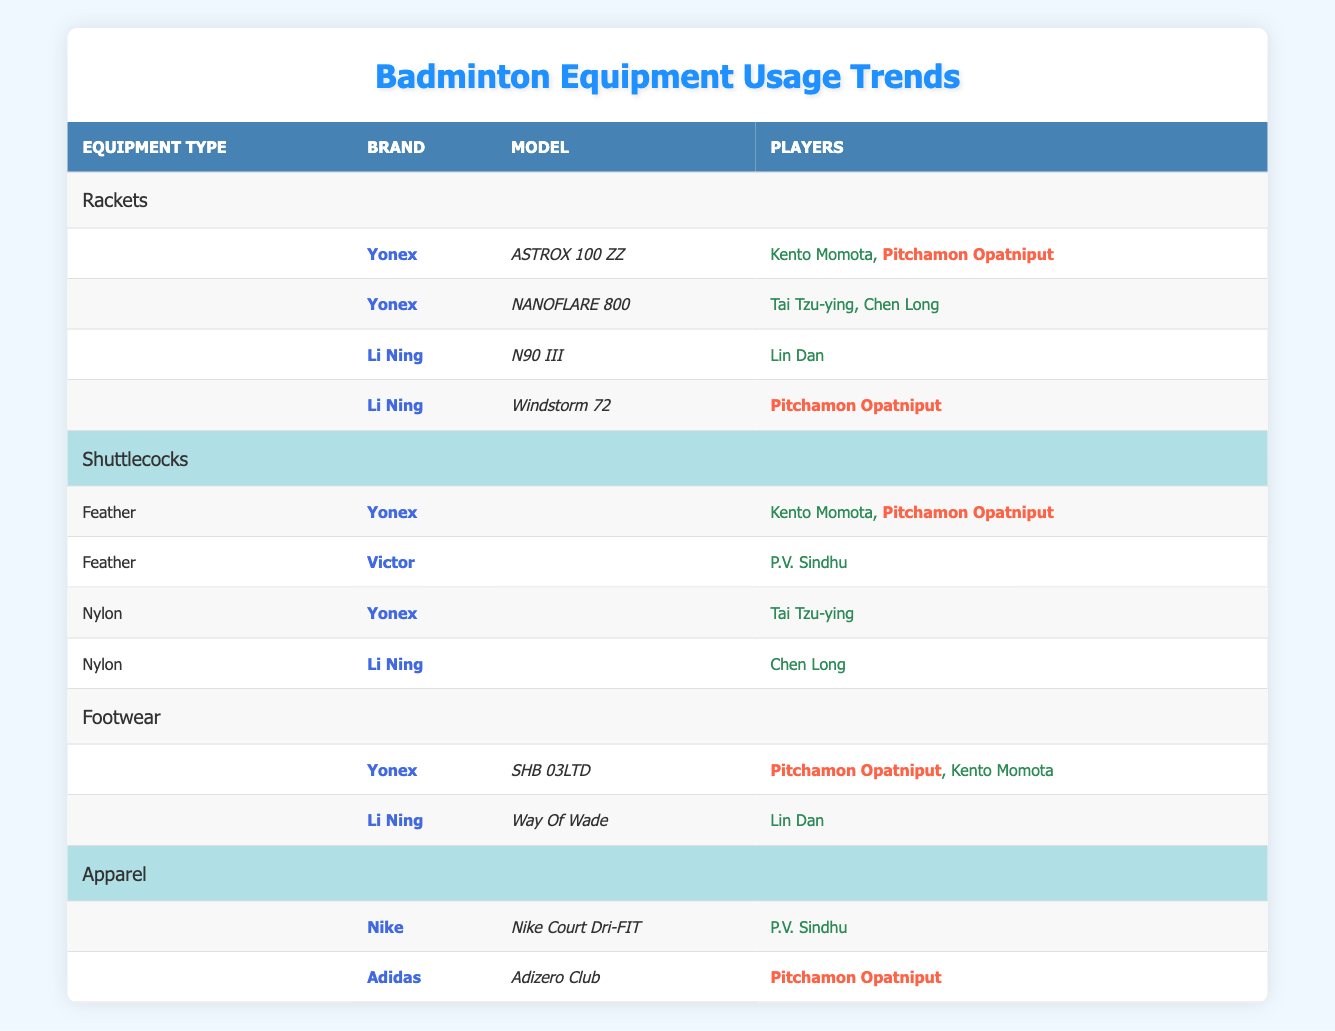What types of rackets does Pitchamon Opatniput use? From the rackets section of the table, I can see that Pitchamon Opatniput uses two models: "ASTROX 100 ZZ" by Yonex and "Windstorm 72" by Li Ning.
Answer: "ASTROX 100 ZZ" and "Windstorm 72" Which brands of footwear are used by Kento Momota? Looking under the footwear section, Kento Momota uses footwear from the brand Yonex, specifically the model "SHB 03LTD." There are no other brands listed for him in the table.
Answer: Yonex True or False: Pitchamon Opatniput uses shuttlecocks from both Yonex and Victor. The table indicates that Pitchamon Opatniput is associated with shuttlecocks from Yonex, but there is no mention of using Victor. Therefore, this statement is false.
Answer: False How many different types of apparel does Pitchamon Opatniput wear according to the table? The table shows that Pitchamon Opatniput uses apparel from Adidas with the model "Adizero Club." There are no other apparel brands listed for her. Thus, there is just one type of apparel.
Answer: 1 If you sum the total number of different racket models used by all players mentioned, what is the total? Upon examining the rackets section, there are four unique racket models: "ASTROX 100 ZZ," "NANOFLARE 800," "N90 III," and "Windstorm 72." Therefore, the total number of different racket models used by all players is 4.
Answer: 4 Which brands of shuttlecocks does Tai Tzu-ying use? In the nylon shuttlecock section, Tai Tzu-ying is listed as using Yonex. There are no other shuttlecock brands associated with Tai Tzu-ying in the table.
Answer: Yonex What is the brand and model of the footwear that Pitchamon Opatniput uses? The footwear section reveals that Pitchamon Opatniput uses the "SHB 03LTD" model from the brand Yonex, along with another brand mentioned. Hence, the brand and model are Yonex and "SHB 03LTD," respectively.
Answer: Yonex, SHB 03LTD How many players use the "Adizero Club" apparel model? The apparel section shows that only P.V. Sindhu uses "Nike Court Dri-FIT," while Pitchamon Opatniput is the only one listed for the "Adizero Club" model from Adidas. Hence, only one player uses this model.
Answer: 1 Which players use the "N90 III" racket model? The table indicates that only Lin Dan uses the "N90 III" model, as it is specifically noted alongside his name.
Answer: Lin Dan 